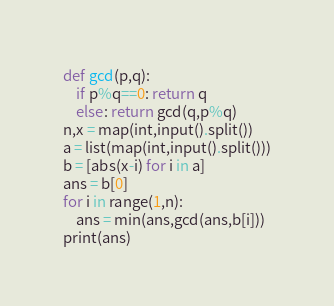Convert code to text. <code><loc_0><loc_0><loc_500><loc_500><_Python_>def gcd(p,q):
    if p%q==0: return q
    else: return gcd(q,p%q)
n,x = map(int,input().split())
a = list(map(int,input().split()))
b = [abs(x-i) for i in a]
ans = b[0]
for i in range(1,n):
    ans = min(ans,gcd(ans,b[i]))
print(ans)</code> 